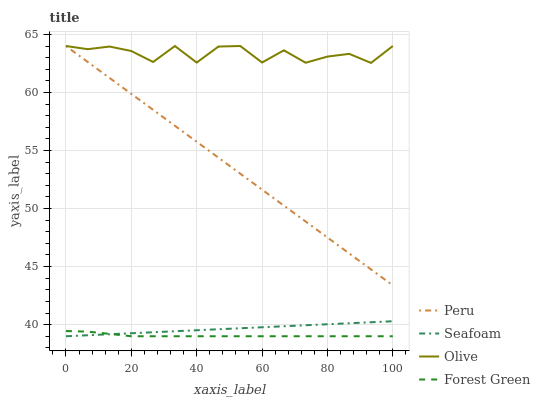Does Forest Green have the minimum area under the curve?
Answer yes or no. Yes. Does Olive have the maximum area under the curve?
Answer yes or no. Yes. Does Seafoam have the minimum area under the curve?
Answer yes or no. No. Does Seafoam have the maximum area under the curve?
Answer yes or no. No. Is Seafoam the smoothest?
Answer yes or no. Yes. Is Olive the roughest?
Answer yes or no. Yes. Is Forest Green the smoothest?
Answer yes or no. No. Is Forest Green the roughest?
Answer yes or no. No. Does Peru have the lowest value?
Answer yes or no. No. Does Peru have the highest value?
Answer yes or no. Yes. Does Seafoam have the highest value?
Answer yes or no. No. Is Seafoam less than Olive?
Answer yes or no. Yes. Is Olive greater than Forest Green?
Answer yes or no. Yes. Does Olive intersect Peru?
Answer yes or no. Yes. Is Olive less than Peru?
Answer yes or no. No. Is Olive greater than Peru?
Answer yes or no. No. Does Seafoam intersect Olive?
Answer yes or no. No. 